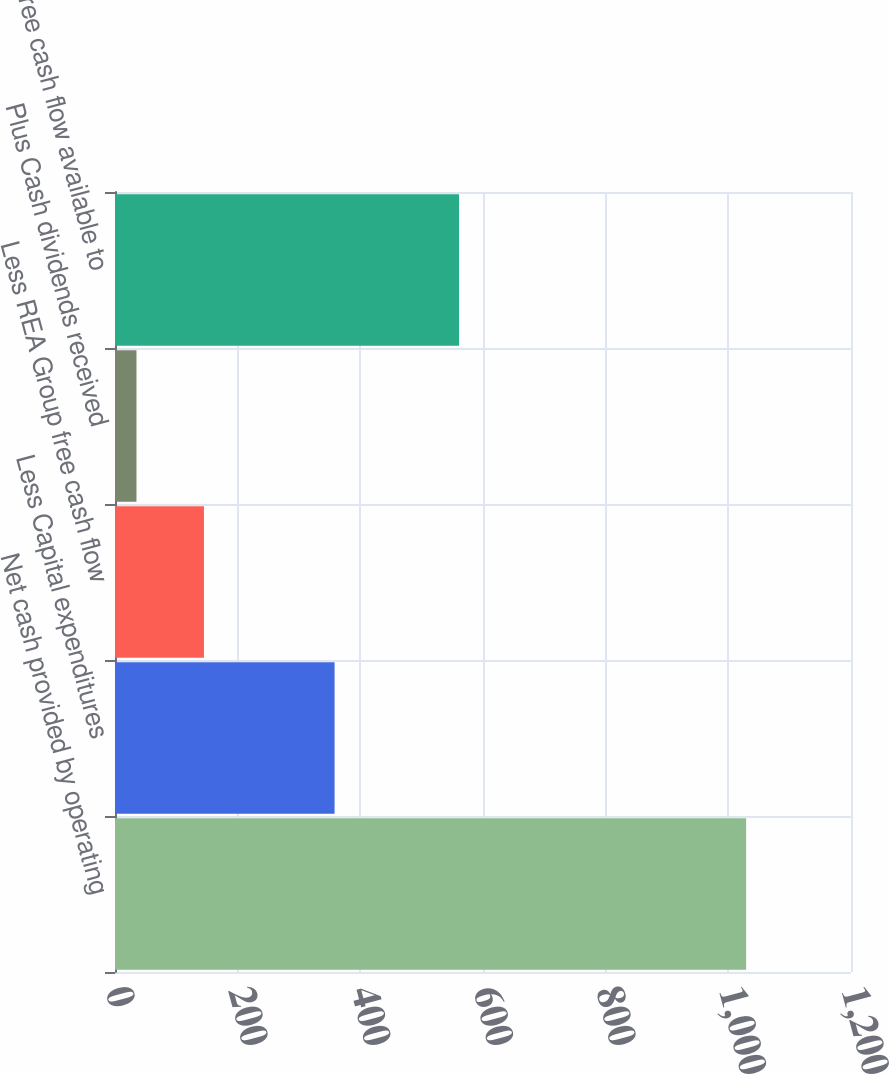<chart> <loc_0><loc_0><loc_500><loc_500><bar_chart><fcel>Net cash provided by operating<fcel>Less Capital expenditures<fcel>Less REA Group free cash flow<fcel>Plus Cash dividends received<fcel>Free cash flow available to<nl><fcel>1029<fcel>358<fcel>145<fcel>35<fcel>561<nl></chart> 